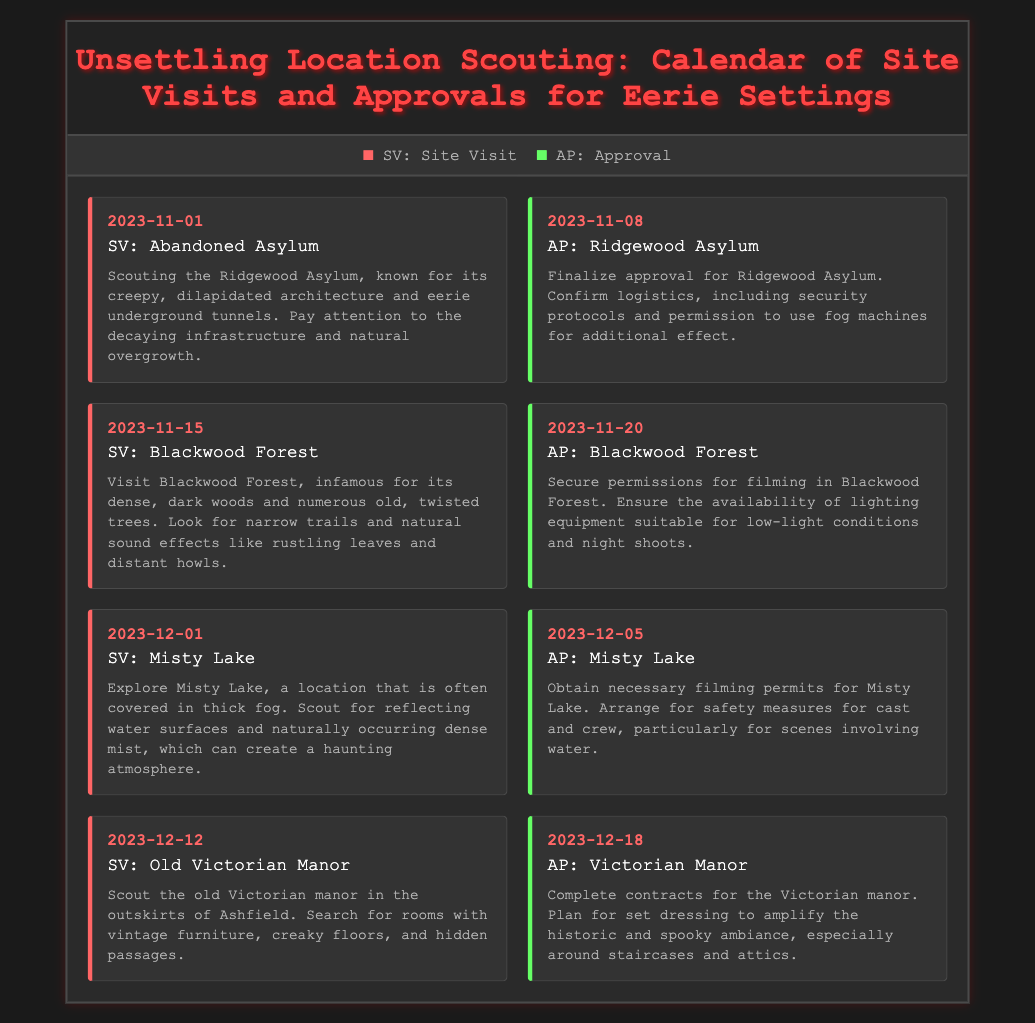What is the first location to be scouted? The first location mentioned for scouting is Ridgewood Asylum.
Answer: Ridgewood Asylum When is the approval for Blackwood Forest scheduled? The approval for Blackwood Forest is scheduled for November 20, 2023.
Answer: November 20, 2023 How many site visits are listed in the calendar? There are four site visits listed in the calendar.
Answer: Four What is a significant feature of Misty Lake? A significant feature of Misty Lake is that it is often covered in thick fog.
Answer: Thick fog What kind of effects are planned for Ridgewood Asylum? Fog machines are planned for additional effect at Ridgewood Asylum.
Answer: Fog machines What is the purpose of the visit to the Old Victorian Manor? The purpose is to scout for vintage furniture, creaky floors, and hidden passages.
Answer: Vintage furniture, creaky floors, hidden passages When is the site visit to Misty Lake? The site visit to Misty Lake is on December 1, 2023.
Answer: December 1, 2023 What color is the label for approvals in the legend? The label for approvals is green.
Answer: Green How is the ambiance planned to be amplified in the Victorian manor? The ambiance is planned to be amplified by set dressing, especially around staircases and attics.
Answer: Set dressing, staircases, attics 